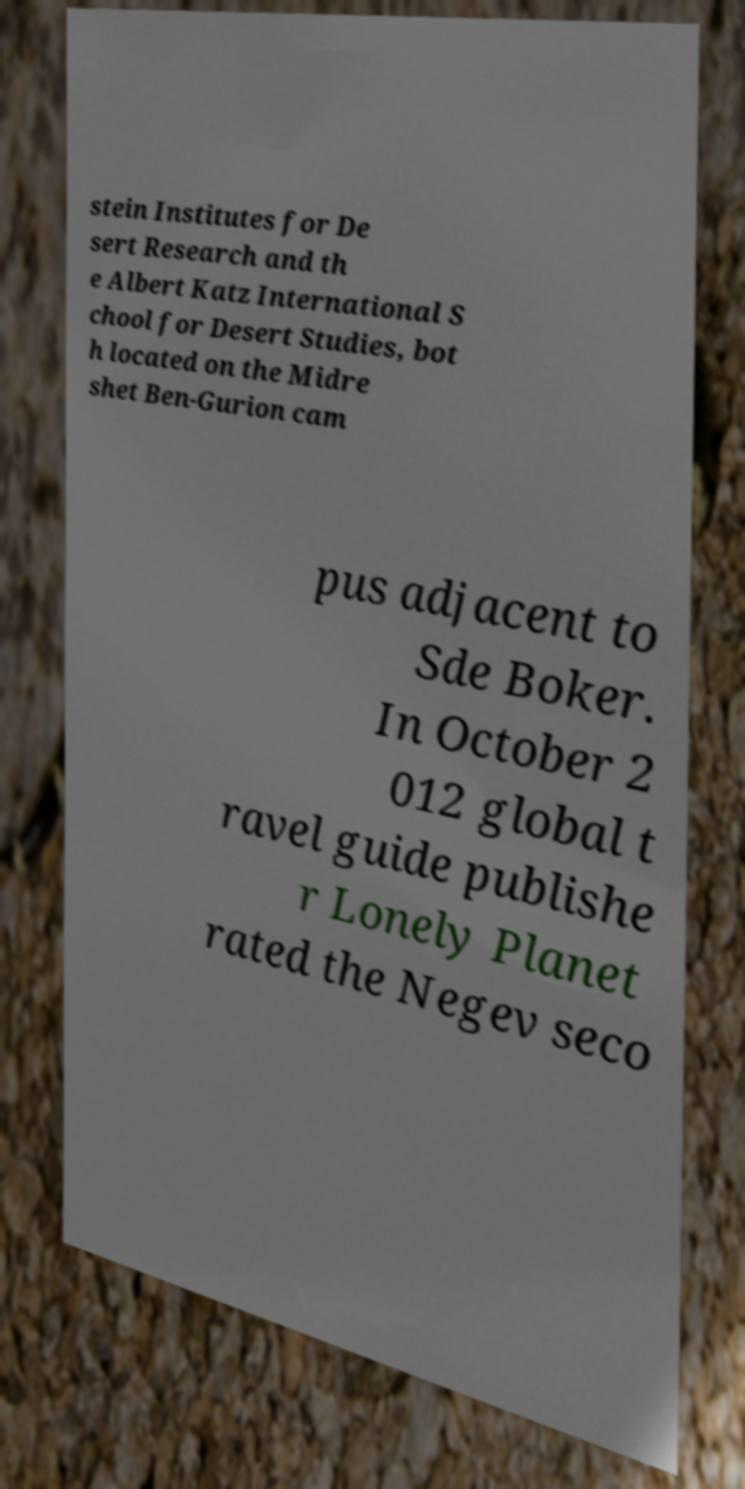Please read and relay the text visible in this image. What does it say? stein Institutes for De sert Research and th e Albert Katz International S chool for Desert Studies, bot h located on the Midre shet Ben-Gurion cam pus adjacent to Sde Boker. In October 2 012 global t ravel guide publishe r Lonely Planet rated the Negev seco 